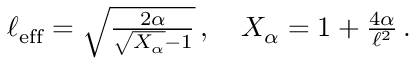Convert formula to latex. <formula><loc_0><loc_0><loc_500><loc_500>\begin{array} { r } { \ell _ { e f f } = \sqrt { \frac { 2 \alpha } { \sqrt { X _ { \alpha } } - 1 } } \, , \quad X _ { \alpha } = 1 + \frac { 4 \alpha } { \ell ^ { 2 } } \, . } \end{array}</formula> 